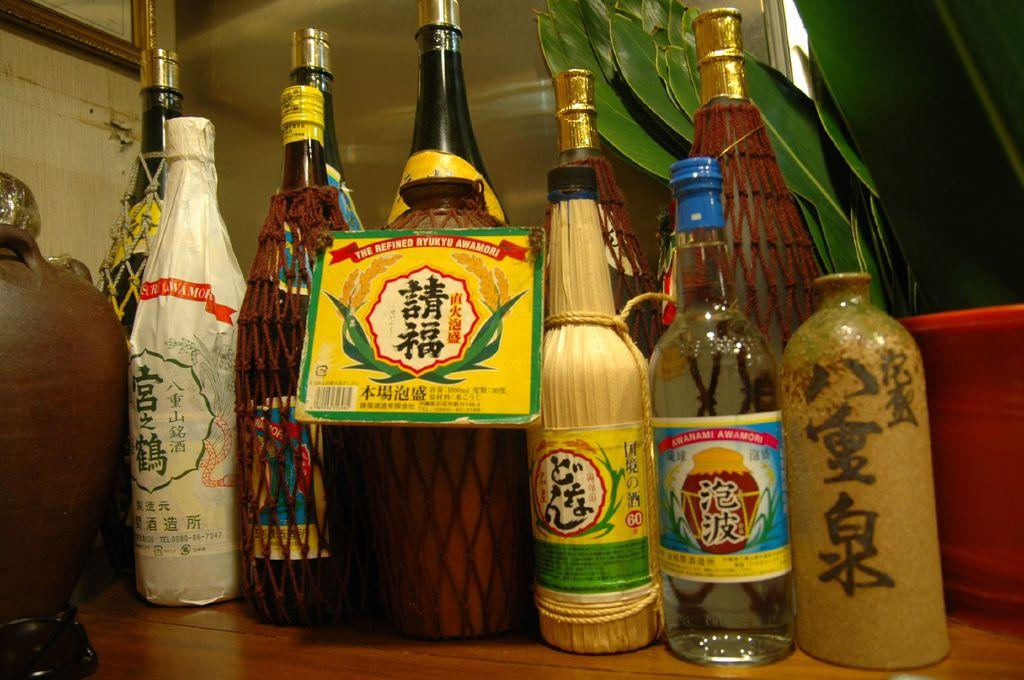<image>
Present a compact description of the photo's key features. Sevral bottles of different drinks are aranged with most having Japanese characters on their labels. 